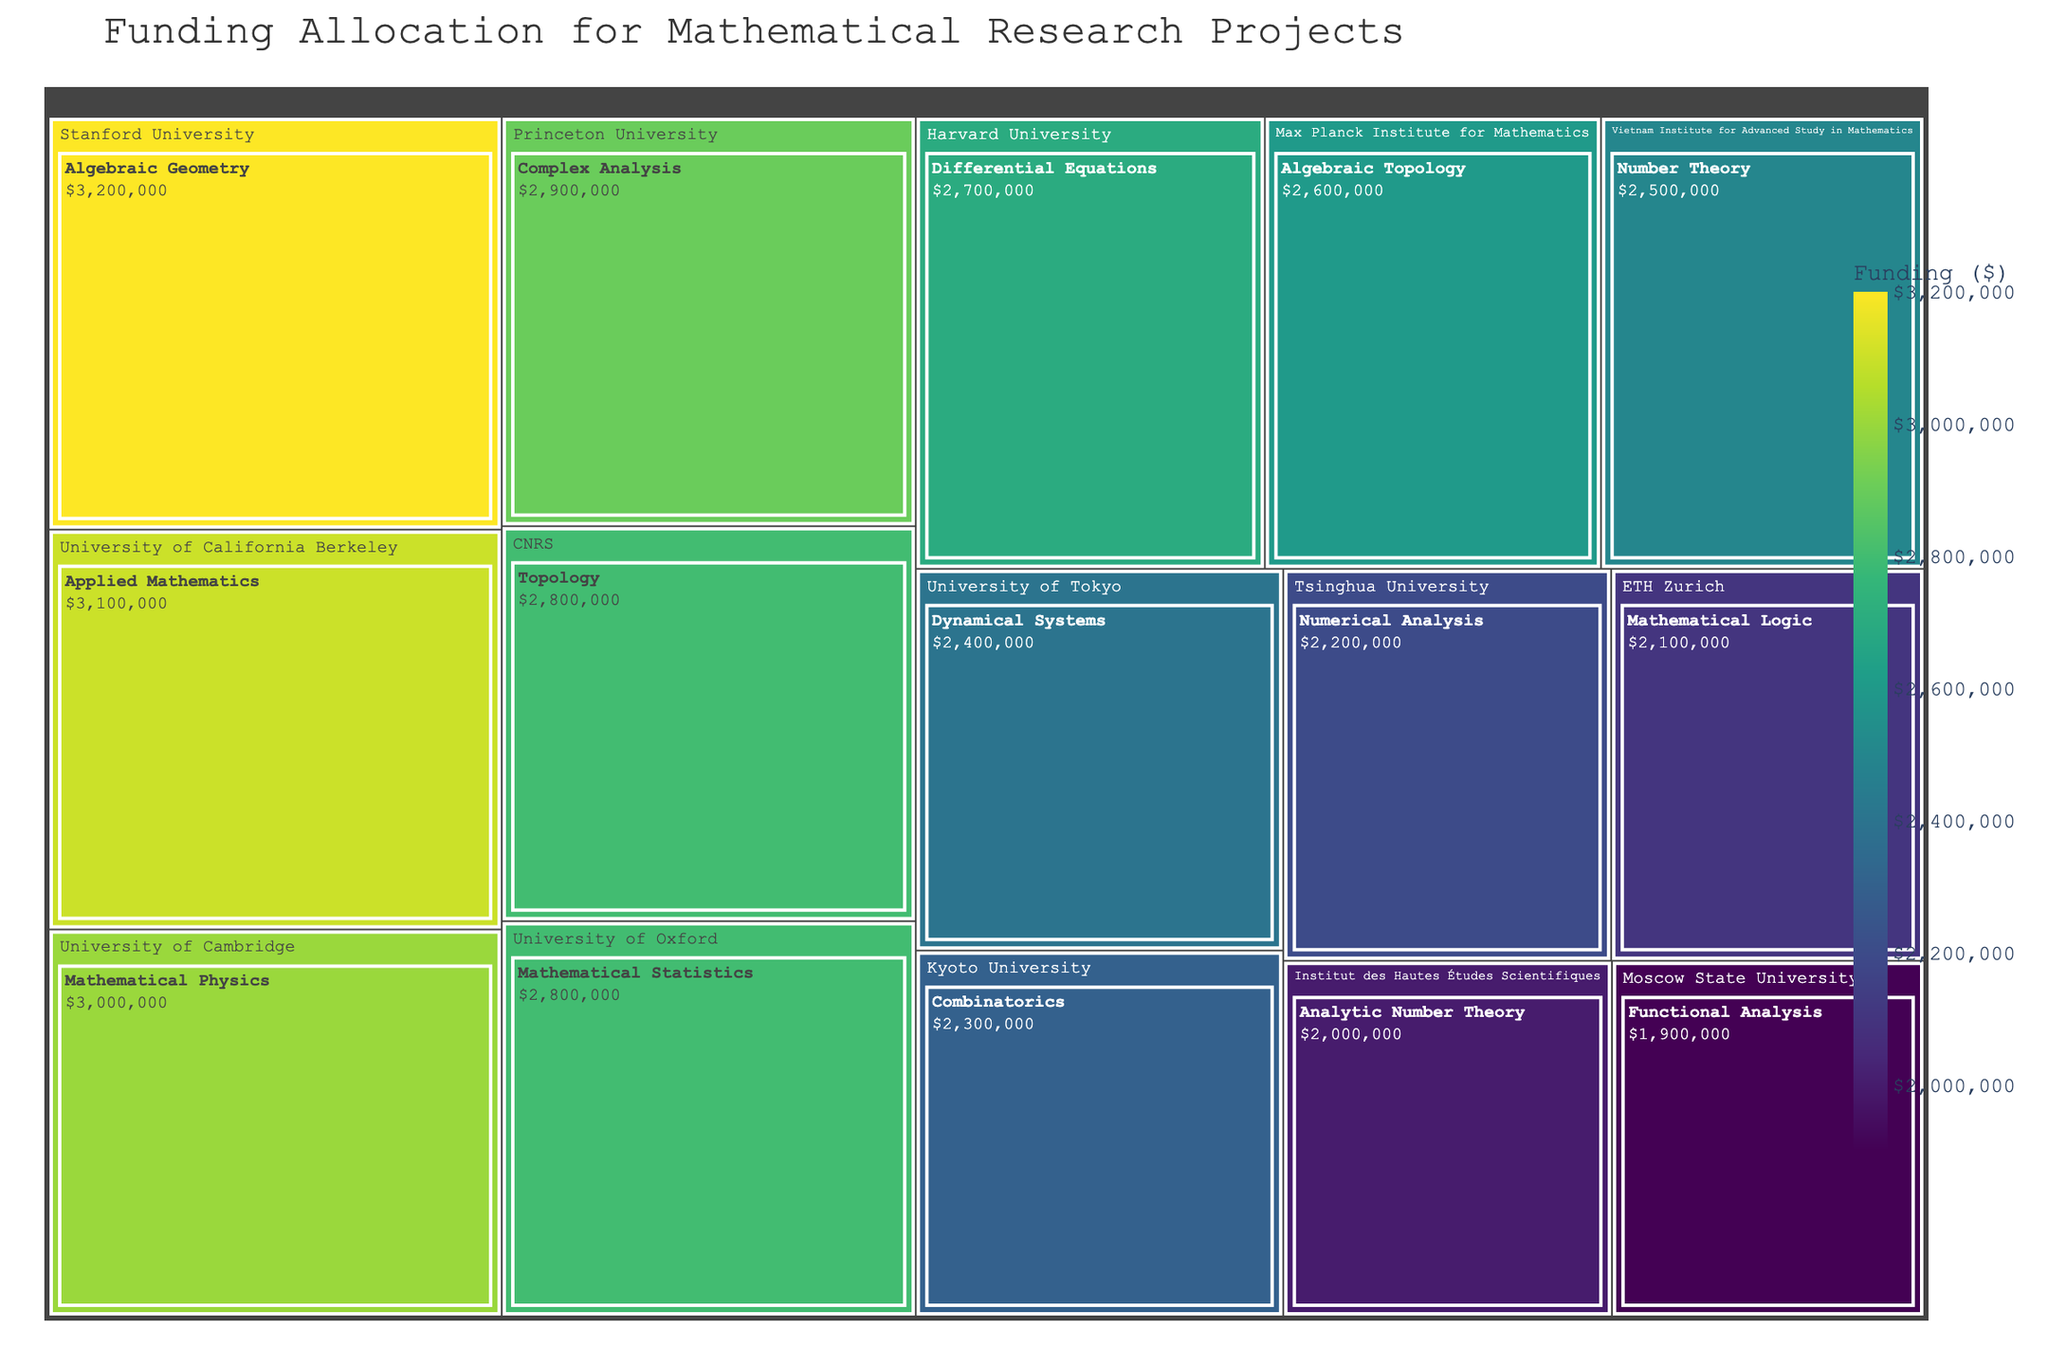what is the title of the treemap? The title is located at the top of the figure and provides an overview of the content being displayed.
Answer: Funding Allocation for Mathematical Research Projects How much funding is allocated to Algebraic Geometry at Stanford University? The treemap uses labels to display funding amounts for each specialization under the respective institution. Locate Stanford University and look for Algebraic Geometry.
Answer: $3,200,000 Which institution has the highest funding for its specialization? Identify the tile with the largest area and the highest funding amount. The color intensity will also help in identifying higher funding.
Answer: Stanford University for Algebraic Geometry What's the total amount of funding allocated to institutions in the USA? Sum the funding for each institution located in the USA: Stanford University ($3,200,000), Harvard University ($2,700,000), University of California Berkeley ($3,100,000), and Princeton University ($2,900,000).
Answer: $11,900,000 How does the funding for Applied Mathematics at University of California Berkeley compare to Differential Equations at Harvard University? Identify the funding for both specializations and compare the amounts visually. Applied Mathematics has $3,100,000 and Differential Equations has $2,700,000.
Answer: Applied Mathematics at UC Berkeley has $400,000 more funding Which institution received the least funding? Locate the smallest tile or the tile with the least intense color, corresponding to the lowest funding value.
Answer: Moscow State University for Functional Analysis What's the combined funding for Number Theory at Vietnam Institute for Advanced Study in Mathematics and Combinatorics at Kyoto University? Sum the funding amounts for Number Theory ($2,500,000) and Combinatorics ($2,300,000).
Answer: $4,800,000 Which specialization is funded at University of Tokyo, and what is the amount? Look for University of Tokyo and locate the specific specialization displayed along with its funding.
Answer: Dynamical Systems, $2,400,000 What is the average funding amount across all specializations? Calculate the sum of all funding amounts and divide by the number of specializations (15). Total funding is $40,700,000 and there are 15 specializations.
Answer: $2,713,333 Compare the funding for Mathematical Physics at University of Cambridge with Complex Analysis at Princeton University. Which one is higher and by how much? Find the funding amounts for both specializations. Mathematical Physics is $3,000,000 and Complex Analysis is $2,900,000, then calculate the difference.
Answer: Mathematical Physics at Cambridge is higher by $100,000 